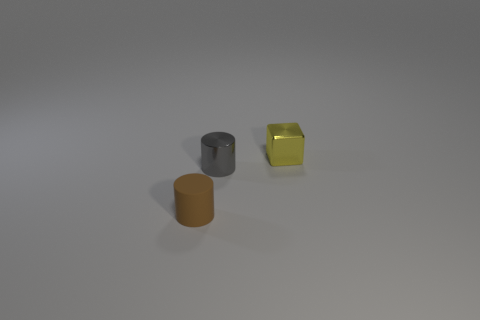There is a tiny cylinder behind the object that is in front of the small cylinder behind the matte cylinder; what is its material?
Give a very brief answer. Metal. Are there any metallic things that have the same size as the matte cylinder?
Your answer should be compact. Yes. There is a cube that is made of the same material as the gray object; what size is it?
Provide a short and direct response. Small. What is the shape of the tiny brown object?
Provide a short and direct response. Cylinder. Do the tiny yellow object and the tiny cylinder that is on the right side of the rubber cylinder have the same material?
Ensure brevity in your answer.  Yes. How many objects are either tiny yellow metallic things or tiny green rubber blocks?
Ensure brevity in your answer.  1. Is there a metallic block?
Offer a very short reply. Yes. There is a metal object behind the metal object that is left of the yellow metallic block; what shape is it?
Give a very brief answer. Cube. How many things are either objects behind the tiny gray shiny thing or things that are right of the tiny brown thing?
Ensure brevity in your answer.  2. There is a brown cylinder that is the same size as the gray metal thing; what is its material?
Your answer should be compact. Rubber. 